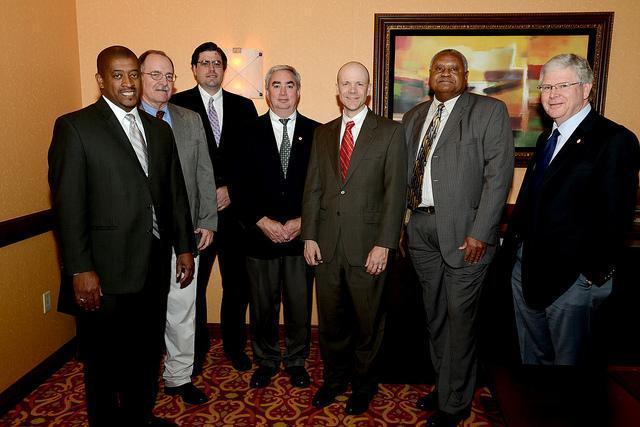How many men are wearing Khaki pants?
Give a very brief answer. 1. How many women are in the picture?
Give a very brief answer. 0. How many people are holding a letter?
Give a very brief answer. 0. How many ties are there?
Give a very brief answer. 7. How many men are in the picture?
Give a very brief answer. 7. How many people are in the photo?
Give a very brief answer. 7. How many cars have a surfboard on them?
Give a very brief answer. 0. 